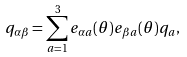Convert formula to latex. <formula><loc_0><loc_0><loc_500><loc_500>q _ { \alpha \beta } = \sum ^ { 3 } _ { a = 1 } e _ { \alpha a } ( \theta ) e _ { \beta a } ( \theta ) q _ { a } ,</formula> 